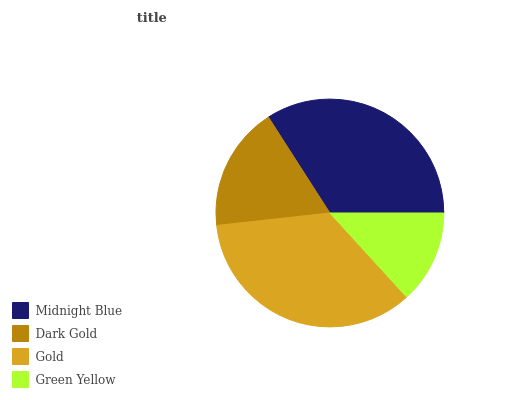Is Green Yellow the minimum?
Answer yes or no. Yes. Is Gold the maximum?
Answer yes or no. Yes. Is Dark Gold the minimum?
Answer yes or no. No. Is Dark Gold the maximum?
Answer yes or no. No. Is Midnight Blue greater than Dark Gold?
Answer yes or no. Yes. Is Dark Gold less than Midnight Blue?
Answer yes or no. Yes. Is Dark Gold greater than Midnight Blue?
Answer yes or no. No. Is Midnight Blue less than Dark Gold?
Answer yes or no. No. Is Midnight Blue the high median?
Answer yes or no. Yes. Is Dark Gold the low median?
Answer yes or no. Yes. Is Green Yellow the high median?
Answer yes or no. No. Is Midnight Blue the low median?
Answer yes or no. No. 